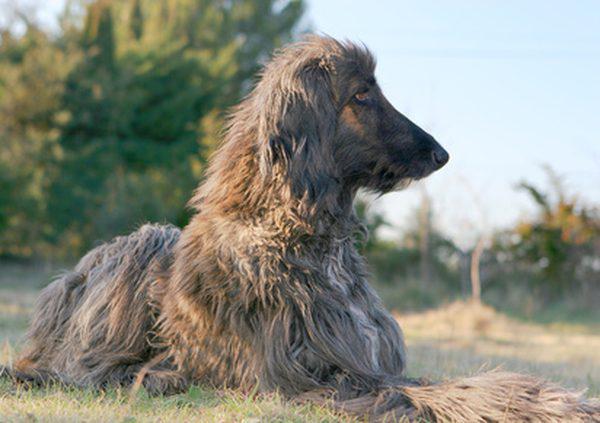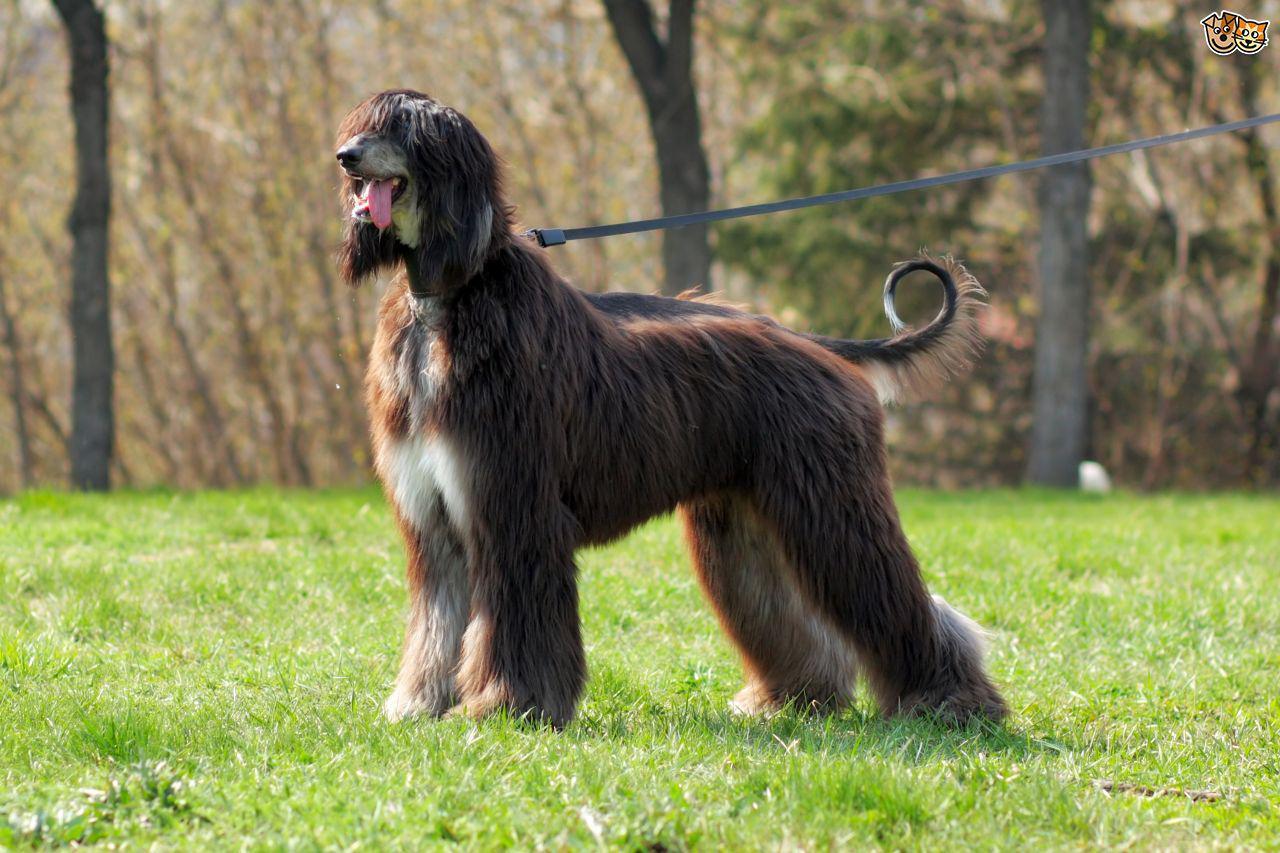The first image is the image on the left, the second image is the image on the right. Analyze the images presented: Is the assertion "In 1 image, 1 dog is standing to the left in grass." valid? Answer yes or no. Yes. The first image is the image on the left, the second image is the image on the right. For the images displayed, is the sentence "One image shows a mostly black dog sitting upright in the grass." factually correct? Answer yes or no. No. 